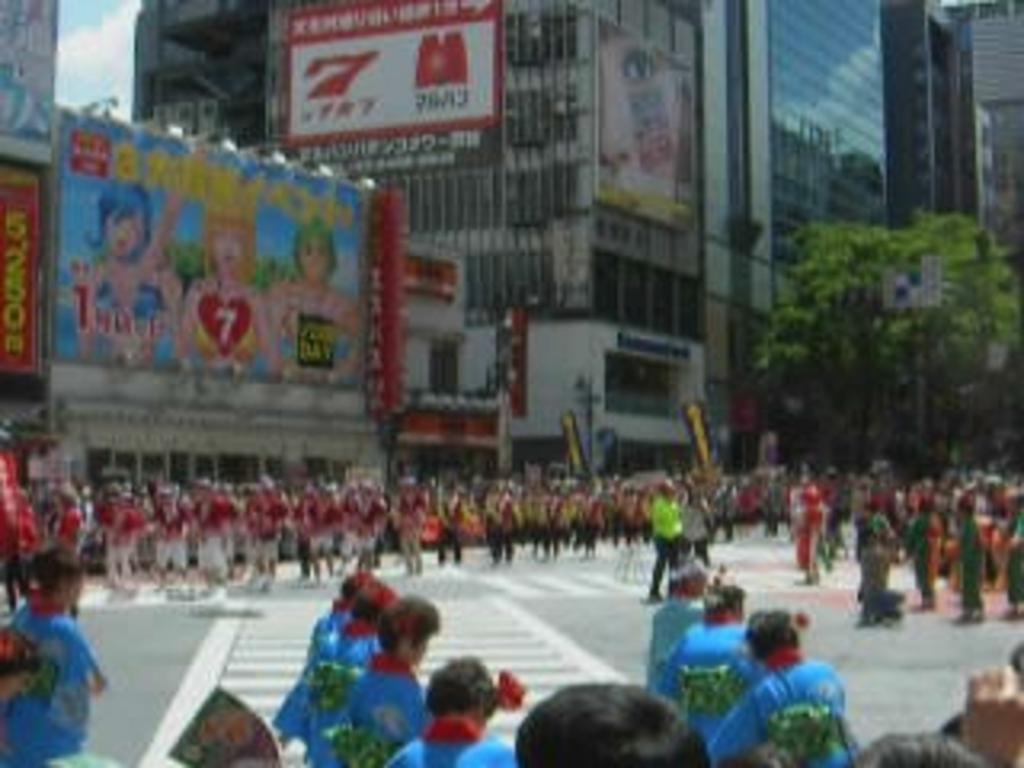Describe this image in one or two sentences. In this picture I can see a group of people are standing on the road. In the background, I can see buildings and a tree. On the left side I can see the sky. 